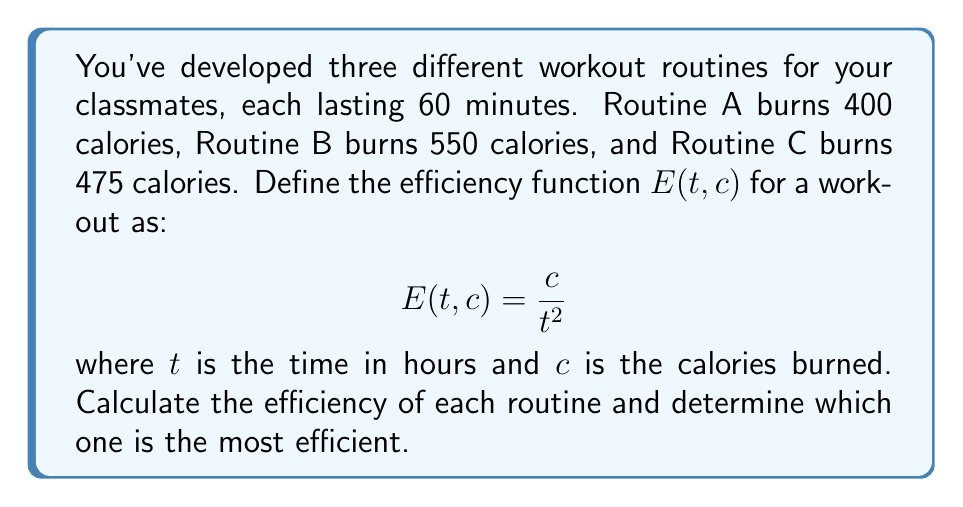Help me with this question. To solve this problem, we need to apply the efficiency function to each routine:

1) First, convert the time from minutes to hours:
   60 minutes = 1 hour

2) Now, let's calculate the efficiency for each routine:

   Routine A: $E_A = \frac{400}{1^2} = 400$

   Routine B: $E_B = \frac{550}{1^2} = 550$

   Routine C: $E_C = \frac{475}{1^2} = 475$

3) The efficiency function $E(t, c) = \frac{c}{t^2}$ measures how many calories are burned per square hour. A higher value indicates a more efficient workout.

4) Comparing the efficiencies:
   $E_B > E_C > E_A$

Therefore, Routine B is the most efficient, followed by Routine C, and then Routine A.
Answer: Routine B is the most efficient with an efficiency of 550 calories per square hour. 